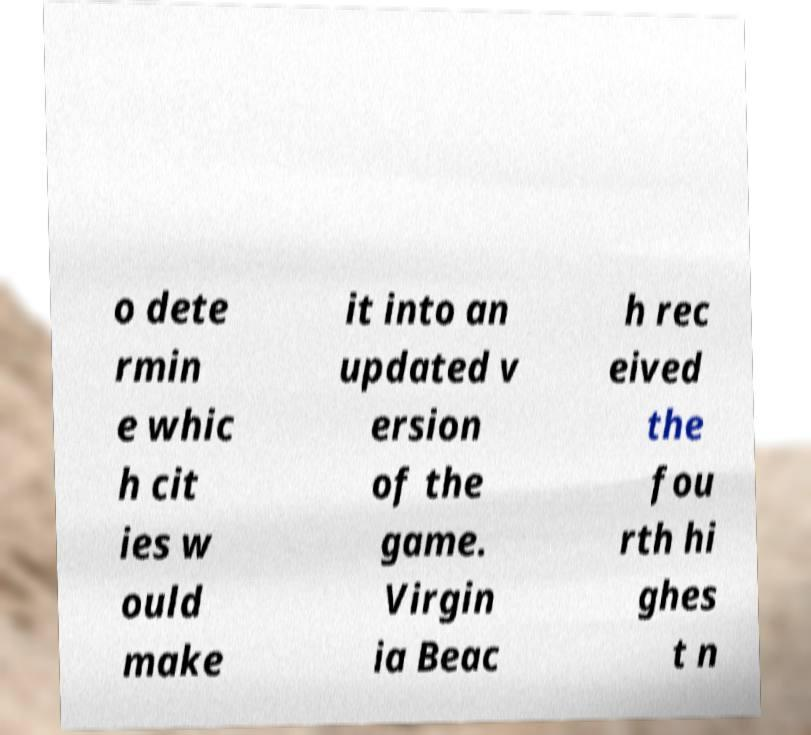Can you accurately transcribe the text from the provided image for me? o dete rmin e whic h cit ies w ould make it into an updated v ersion of the game. Virgin ia Beac h rec eived the fou rth hi ghes t n 